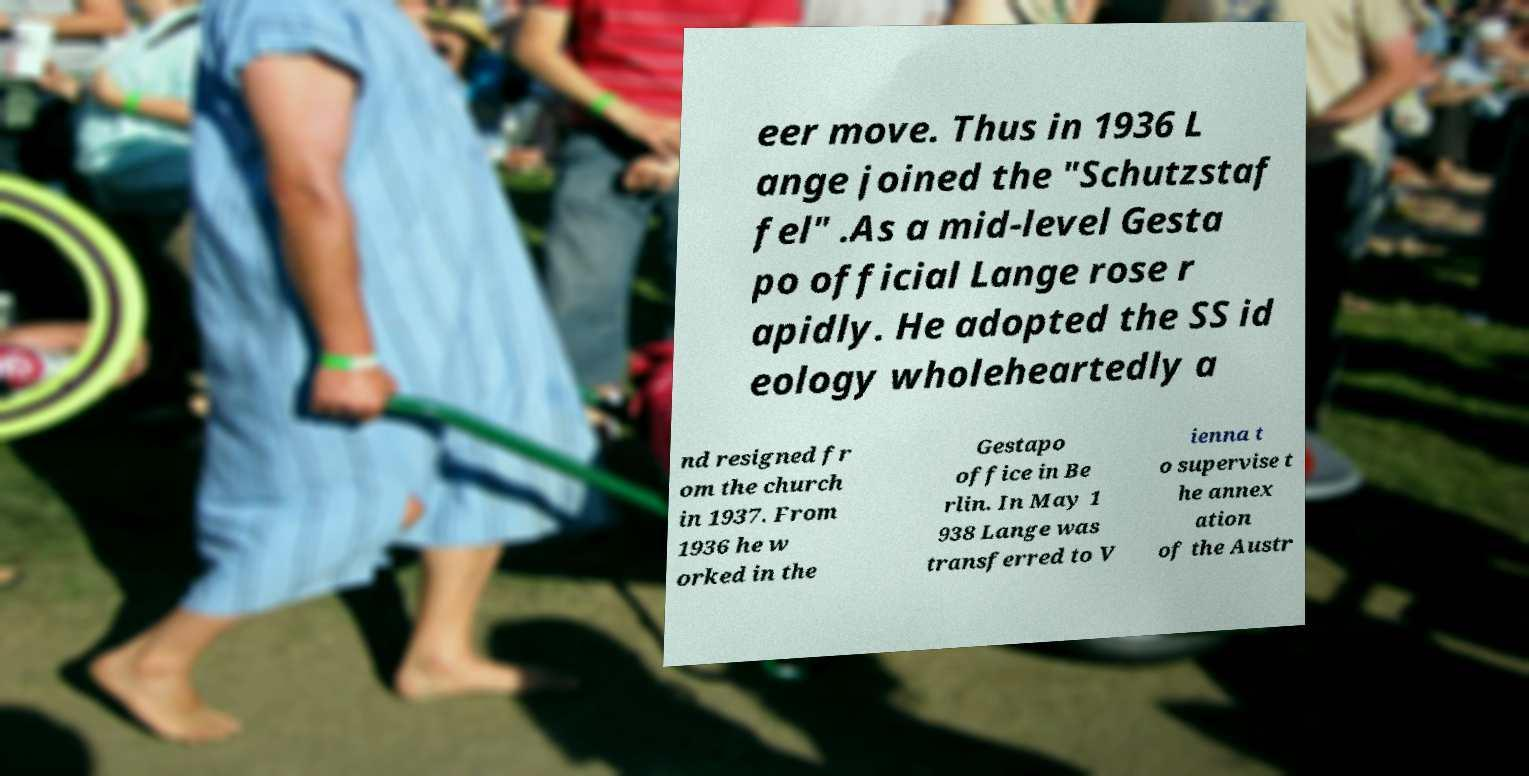What messages or text are displayed in this image? I need them in a readable, typed format. eer move. Thus in 1936 L ange joined the "Schutzstaf fel" .As a mid-level Gesta po official Lange rose r apidly. He adopted the SS id eology wholeheartedly a nd resigned fr om the church in 1937. From 1936 he w orked in the Gestapo office in Be rlin. In May 1 938 Lange was transferred to V ienna t o supervise t he annex ation of the Austr 